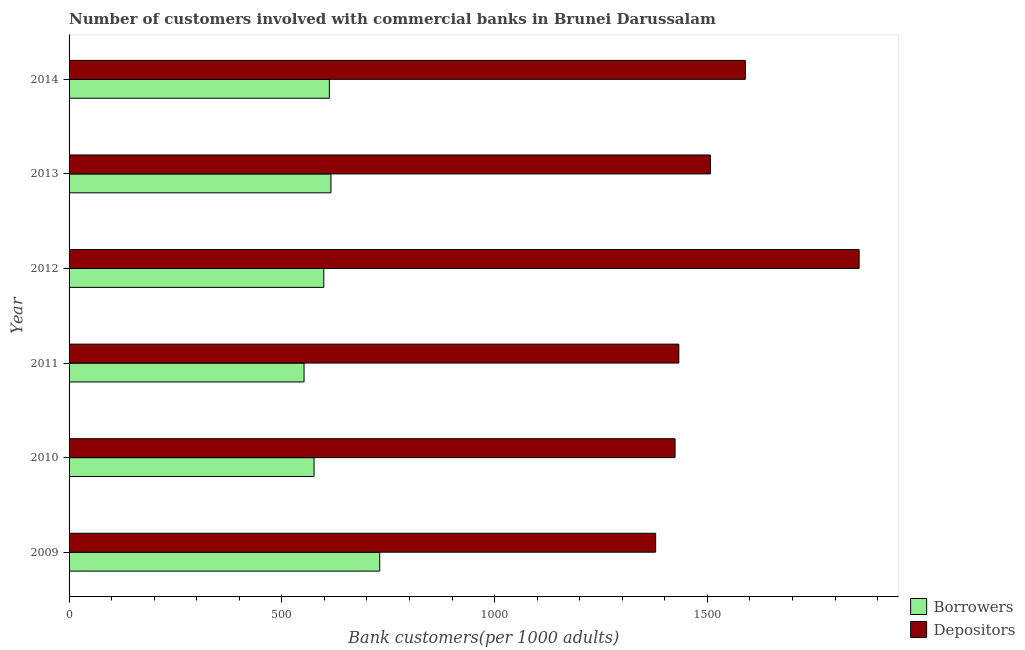How many groups of bars are there?
Your response must be concise. 6. Are the number of bars on each tick of the Y-axis equal?
Provide a short and direct response. Yes. What is the label of the 1st group of bars from the top?
Offer a very short reply. 2014. In how many cases, is the number of bars for a given year not equal to the number of legend labels?
Keep it short and to the point. 0. What is the number of borrowers in 2010?
Provide a short and direct response. 575.73. Across all years, what is the maximum number of depositors?
Offer a very short reply. 1856.6. Across all years, what is the minimum number of borrowers?
Your response must be concise. 552.23. In which year was the number of depositors maximum?
Keep it short and to the point. 2012. In which year was the number of depositors minimum?
Your response must be concise. 2009. What is the total number of borrowers in the graph?
Keep it short and to the point. 3683.61. What is the difference between the number of depositors in 2009 and that in 2011?
Make the answer very short. -54.42. What is the difference between the number of borrowers in 2010 and the number of depositors in 2011?
Provide a succinct answer. -857.14. What is the average number of borrowers per year?
Give a very brief answer. 613.93. In the year 2014, what is the difference between the number of borrowers and number of depositors?
Ensure brevity in your answer.  -977.51. What is the ratio of the number of depositors in 2012 to that in 2014?
Your response must be concise. 1.17. What is the difference between the highest and the second highest number of borrowers?
Your response must be concise. 114.64. What is the difference between the highest and the lowest number of borrowers?
Ensure brevity in your answer.  177.78. What does the 1st bar from the top in 2011 represents?
Ensure brevity in your answer.  Depositors. What does the 2nd bar from the bottom in 2009 represents?
Offer a very short reply. Depositors. Are all the bars in the graph horizontal?
Your answer should be very brief. Yes. How many years are there in the graph?
Keep it short and to the point. 6. Are the values on the major ticks of X-axis written in scientific E-notation?
Ensure brevity in your answer.  No. How are the legend labels stacked?
Give a very brief answer. Vertical. What is the title of the graph?
Offer a very short reply. Number of customers involved with commercial banks in Brunei Darussalam. Does "Foreign liabilities" appear as one of the legend labels in the graph?
Provide a short and direct response. No. What is the label or title of the X-axis?
Your answer should be very brief. Bank customers(per 1000 adults). What is the Bank customers(per 1000 adults) in Borrowers in 2009?
Offer a very short reply. 730.02. What is the Bank customers(per 1000 adults) of Depositors in 2009?
Keep it short and to the point. 1378.46. What is the Bank customers(per 1000 adults) in Borrowers in 2010?
Offer a terse response. 575.73. What is the Bank customers(per 1000 adults) in Depositors in 2010?
Give a very brief answer. 1424.06. What is the Bank customers(per 1000 adults) of Borrowers in 2011?
Ensure brevity in your answer.  552.23. What is the Bank customers(per 1000 adults) of Depositors in 2011?
Your answer should be compact. 1432.88. What is the Bank customers(per 1000 adults) of Borrowers in 2012?
Provide a succinct answer. 598.59. What is the Bank customers(per 1000 adults) in Depositors in 2012?
Keep it short and to the point. 1856.6. What is the Bank customers(per 1000 adults) of Borrowers in 2013?
Your answer should be very brief. 615.37. What is the Bank customers(per 1000 adults) of Depositors in 2013?
Provide a succinct answer. 1507.03. What is the Bank customers(per 1000 adults) of Borrowers in 2014?
Provide a short and direct response. 611.66. What is the Bank customers(per 1000 adults) of Depositors in 2014?
Provide a short and direct response. 1589.17. Across all years, what is the maximum Bank customers(per 1000 adults) in Borrowers?
Your response must be concise. 730.02. Across all years, what is the maximum Bank customers(per 1000 adults) in Depositors?
Offer a terse response. 1856.6. Across all years, what is the minimum Bank customers(per 1000 adults) of Borrowers?
Keep it short and to the point. 552.23. Across all years, what is the minimum Bank customers(per 1000 adults) in Depositors?
Provide a short and direct response. 1378.46. What is the total Bank customers(per 1000 adults) in Borrowers in the graph?
Provide a succinct answer. 3683.61. What is the total Bank customers(per 1000 adults) in Depositors in the graph?
Provide a succinct answer. 9188.2. What is the difference between the Bank customers(per 1000 adults) of Borrowers in 2009 and that in 2010?
Offer a terse response. 154.28. What is the difference between the Bank customers(per 1000 adults) of Depositors in 2009 and that in 2010?
Your answer should be compact. -45.61. What is the difference between the Bank customers(per 1000 adults) of Borrowers in 2009 and that in 2011?
Make the answer very short. 177.78. What is the difference between the Bank customers(per 1000 adults) in Depositors in 2009 and that in 2011?
Ensure brevity in your answer.  -54.42. What is the difference between the Bank customers(per 1000 adults) in Borrowers in 2009 and that in 2012?
Offer a very short reply. 131.43. What is the difference between the Bank customers(per 1000 adults) in Depositors in 2009 and that in 2012?
Offer a very short reply. -478.14. What is the difference between the Bank customers(per 1000 adults) in Borrowers in 2009 and that in 2013?
Ensure brevity in your answer.  114.64. What is the difference between the Bank customers(per 1000 adults) of Depositors in 2009 and that in 2013?
Provide a succinct answer. -128.58. What is the difference between the Bank customers(per 1000 adults) of Borrowers in 2009 and that in 2014?
Your answer should be very brief. 118.35. What is the difference between the Bank customers(per 1000 adults) of Depositors in 2009 and that in 2014?
Your response must be concise. -210.72. What is the difference between the Bank customers(per 1000 adults) in Borrowers in 2010 and that in 2011?
Your answer should be compact. 23.5. What is the difference between the Bank customers(per 1000 adults) of Depositors in 2010 and that in 2011?
Provide a succinct answer. -8.82. What is the difference between the Bank customers(per 1000 adults) in Borrowers in 2010 and that in 2012?
Provide a short and direct response. -22.86. What is the difference between the Bank customers(per 1000 adults) of Depositors in 2010 and that in 2012?
Provide a succinct answer. -432.53. What is the difference between the Bank customers(per 1000 adults) in Borrowers in 2010 and that in 2013?
Provide a succinct answer. -39.64. What is the difference between the Bank customers(per 1000 adults) of Depositors in 2010 and that in 2013?
Make the answer very short. -82.97. What is the difference between the Bank customers(per 1000 adults) in Borrowers in 2010 and that in 2014?
Keep it short and to the point. -35.93. What is the difference between the Bank customers(per 1000 adults) in Depositors in 2010 and that in 2014?
Ensure brevity in your answer.  -165.11. What is the difference between the Bank customers(per 1000 adults) of Borrowers in 2011 and that in 2012?
Provide a short and direct response. -46.36. What is the difference between the Bank customers(per 1000 adults) of Depositors in 2011 and that in 2012?
Your answer should be compact. -423.72. What is the difference between the Bank customers(per 1000 adults) in Borrowers in 2011 and that in 2013?
Your answer should be compact. -63.14. What is the difference between the Bank customers(per 1000 adults) of Depositors in 2011 and that in 2013?
Offer a terse response. -74.15. What is the difference between the Bank customers(per 1000 adults) in Borrowers in 2011 and that in 2014?
Provide a short and direct response. -59.43. What is the difference between the Bank customers(per 1000 adults) of Depositors in 2011 and that in 2014?
Make the answer very short. -156.3. What is the difference between the Bank customers(per 1000 adults) of Borrowers in 2012 and that in 2013?
Your answer should be very brief. -16.78. What is the difference between the Bank customers(per 1000 adults) in Depositors in 2012 and that in 2013?
Offer a very short reply. 349.56. What is the difference between the Bank customers(per 1000 adults) in Borrowers in 2012 and that in 2014?
Keep it short and to the point. -13.07. What is the difference between the Bank customers(per 1000 adults) of Depositors in 2012 and that in 2014?
Give a very brief answer. 267.42. What is the difference between the Bank customers(per 1000 adults) of Borrowers in 2013 and that in 2014?
Give a very brief answer. 3.71. What is the difference between the Bank customers(per 1000 adults) in Depositors in 2013 and that in 2014?
Offer a very short reply. -82.14. What is the difference between the Bank customers(per 1000 adults) in Borrowers in 2009 and the Bank customers(per 1000 adults) in Depositors in 2010?
Offer a very short reply. -694.05. What is the difference between the Bank customers(per 1000 adults) of Borrowers in 2009 and the Bank customers(per 1000 adults) of Depositors in 2011?
Offer a terse response. -702.86. What is the difference between the Bank customers(per 1000 adults) of Borrowers in 2009 and the Bank customers(per 1000 adults) of Depositors in 2012?
Provide a succinct answer. -1126.58. What is the difference between the Bank customers(per 1000 adults) in Borrowers in 2009 and the Bank customers(per 1000 adults) in Depositors in 2013?
Give a very brief answer. -777.02. What is the difference between the Bank customers(per 1000 adults) in Borrowers in 2009 and the Bank customers(per 1000 adults) in Depositors in 2014?
Your response must be concise. -859.16. What is the difference between the Bank customers(per 1000 adults) in Borrowers in 2010 and the Bank customers(per 1000 adults) in Depositors in 2011?
Your response must be concise. -857.14. What is the difference between the Bank customers(per 1000 adults) of Borrowers in 2010 and the Bank customers(per 1000 adults) of Depositors in 2012?
Your response must be concise. -1280.86. What is the difference between the Bank customers(per 1000 adults) of Borrowers in 2010 and the Bank customers(per 1000 adults) of Depositors in 2013?
Provide a succinct answer. -931.3. What is the difference between the Bank customers(per 1000 adults) of Borrowers in 2010 and the Bank customers(per 1000 adults) of Depositors in 2014?
Make the answer very short. -1013.44. What is the difference between the Bank customers(per 1000 adults) of Borrowers in 2011 and the Bank customers(per 1000 adults) of Depositors in 2012?
Keep it short and to the point. -1304.36. What is the difference between the Bank customers(per 1000 adults) of Borrowers in 2011 and the Bank customers(per 1000 adults) of Depositors in 2013?
Ensure brevity in your answer.  -954.8. What is the difference between the Bank customers(per 1000 adults) of Borrowers in 2011 and the Bank customers(per 1000 adults) of Depositors in 2014?
Ensure brevity in your answer.  -1036.94. What is the difference between the Bank customers(per 1000 adults) in Borrowers in 2012 and the Bank customers(per 1000 adults) in Depositors in 2013?
Your response must be concise. -908.44. What is the difference between the Bank customers(per 1000 adults) in Borrowers in 2012 and the Bank customers(per 1000 adults) in Depositors in 2014?
Offer a terse response. -990.58. What is the difference between the Bank customers(per 1000 adults) of Borrowers in 2013 and the Bank customers(per 1000 adults) of Depositors in 2014?
Ensure brevity in your answer.  -973.8. What is the average Bank customers(per 1000 adults) in Borrowers per year?
Provide a succinct answer. 613.93. What is the average Bank customers(per 1000 adults) of Depositors per year?
Offer a very short reply. 1531.37. In the year 2009, what is the difference between the Bank customers(per 1000 adults) of Borrowers and Bank customers(per 1000 adults) of Depositors?
Keep it short and to the point. -648.44. In the year 2010, what is the difference between the Bank customers(per 1000 adults) in Borrowers and Bank customers(per 1000 adults) in Depositors?
Your answer should be very brief. -848.33. In the year 2011, what is the difference between the Bank customers(per 1000 adults) in Borrowers and Bank customers(per 1000 adults) in Depositors?
Your answer should be very brief. -880.65. In the year 2012, what is the difference between the Bank customers(per 1000 adults) of Borrowers and Bank customers(per 1000 adults) of Depositors?
Ensure brevity in your answer.  -1258.01. In the year 2013, what is the difference between the Bank customers(per 1000 adults) of Borrowers and Bank customers(per 1000 adults) of Depositors?
Provide a succinct answer. -891.66. In the year 2014, what is the difference between the Bank customers(per 1000 adults) of Borrowers and Bank customers(per 1000 adults) of Depositors?
Provide a succinct answer. -977.51. What is the ratio of the Bank customers(per 1000 adults) of Borrowers in 2009 to that in 2010?
Your answer should be compact. 1.27. What is the ratio of the Bank customers(per 1000 adults) of Depositors in 2009 to that in 2010?
Ensure brevity in your answer.  0.97. What is the ratio of the Bank customers(per 1000 adults) in Borrowers in 2009 to that in 2011?
Provide a short and direct response. 1.32. What is the ratio of the Bank customers(per 1000 adults) of Borrowers in 2009 to that in 2012?
Provide a short and direct response. 1.22. What is the ratio of the Bank customers(per 1000 adults) of Depositors in 2009 to that in 2012?
Ensure brevity in your answer.  0.74. What is the ratio of the Bank customers(per 1000 adults) of Borrowers in 2009 to that in 2013?
Your answer should be compact. 1.19. What is the ratio of the Bank customers(per 1000 adults) of Depositors in 2009 to that in 2013?
Offer a very short reply. 0.91. What is the ratio of the Bank customers(per 1000 adults) of Borrowers in 2009 to that in 2014?
Make the answer very short. 1.19. What is the ratio of the Bank customers(per 1000 adults) in Depositors in 2009 to that in 2014?
Your response must be concise. 0.87. What is the ratio of the Bank customers(per 1000 adults) of Borrowers in 2010 to that in 2011?
Provide a short and direct response. 1.04. What is the ratio of the Bank customers(per 1000 adults) in Borrowers in 2010 to that in 2012?
Ensure brevity in your answer.  0.96. What is the ratio of the Bank customers(per 1000 adults) of Depositors in 2010 to that in 2012?
Offer a terse response. 0.77. What is the ratio of the Bank customers(per 1000 adults) in Borrowers in 2010 to that in 2013?
Give a very brief answer. 0.94. What is the ratio of the Bank customers(per 1000 adults) in Depositors in 2010 to that in 2013?
Provide a succinct answer. 0.94. What is the ratio of the Bank customers(per 1000 adults) in Borrowers in 2010 to that in 2014?
Make the answer very short. 0.94. What is the ratio of the Bank customers(per 1000 adults) in Depositors in 2010 to that in 2014?
Your answer should be compact. 0.9. What is the ratio of the Bank customers(per 1000 adults) of Borrowers in 2011 to that in 2012?
Offer a terse response. 0.92. What is the ratio of the Bank customers(per 1000 adults) of Depositors in 2011 to that in 2012?
Offer a very short reply. 0.77. What is the ratio of the Bank customers(per 1000 adults) in Borrowers in 2011 to that in 2013?
Provide a short and direct response. 0.9. What is the ratio of the Bank customers(per 1000 adults) of Depositors in 2011 to that in 2013?
Your answer should be very brief. 0.95. What is the ratio of the Bank customers(per 1000 adults) of Borrowers in 2011 to that in 2014?
Provide a succinct answer. 0.9. What is the ratio of the Bank customers(per 1000 adults) in Depositors in 2011 to that in 2014?
Give a very brief answer. 0.9. What is the ratio of the Bank customers(per 1000 adults) in Borrowers in 2012 to that in 2013?
Your answer should be very brief. 0.97. What is the ratio of the Bank customers(per 1000 adults) of Depositors in 2012 to that in 2013?
Keep it short and to the point. 1.23. What is the ratio of the Bank customers(per 1000 adults) in Borrowers in 2012 to that in 2014?
Your answer should be very brief. 0.98. What is the ratio of the Bank customers(per 1000 adults) in Depositors in 2012 to that in 2014?
Your answer should be compact. 1.17. What is the ratio of the Bank customers(per 1000 adults) of Depositors in 2013 to that in 2014?
Ensure brevity in your answer.  0.95. What is the difference between the highest and the second highest Bank customers(per 1000 adults) of Borrowers?
Provide a succinct answer. 114.64. What is the difference between the highest and the second highest Bank customers(per 1000 adults) of Depositors?
Offer a very short reply. 267.42. What is the difference between the highest and the lowest Bank customers(per 1000 adults) of Borrowers?
Provide a short and direct response. 177.78. What is the difference between the highest and the lowest Bank customers(per 1000 adults) of Depositors?
Offer a very short reply. 478.14. 